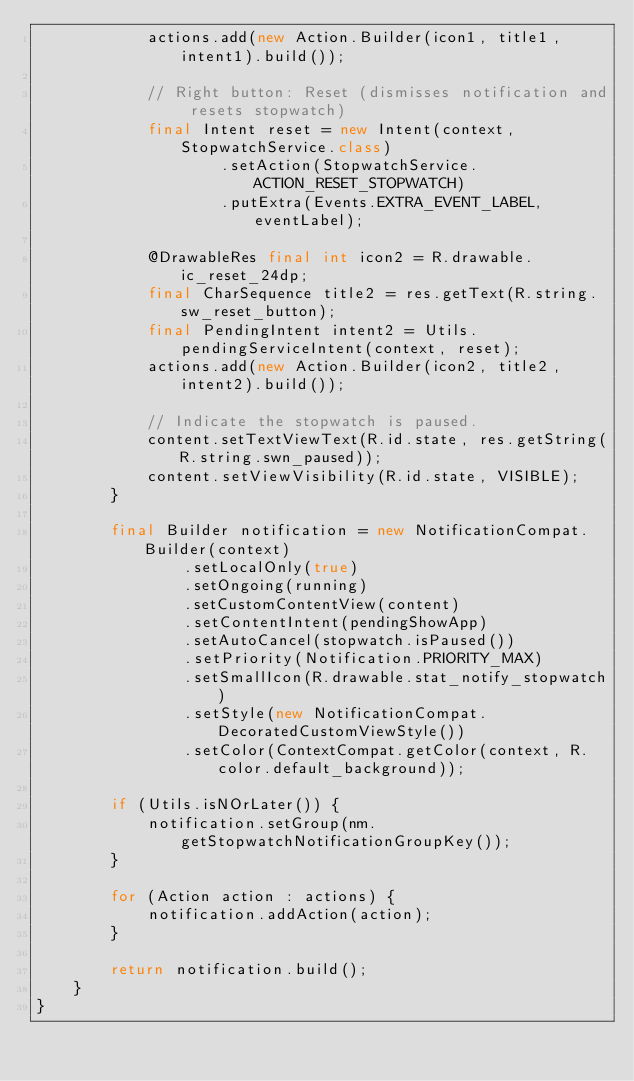Convert code to text. <code><loc_0><loc_0><loc_500><loc_500><_Java_>            actions.add(new Action.Builder(icon1, title1, intent1).build());

            // Right button: Reset (dismisses notification and resets stopwatch)
            final Intent reset = new Intent(context, StopwatchService.class)
                    .setAction(StopwatchService.ACTION_RESET_STOPWATCH)
                    .putExtra(Events.EXTRA_EVENT_LABEL, eventLabel);

            @DrawableRes final int icon2 = R.drawable.ic_reset_24dp;
            final CharSequence title2 = res.getText(R.string.sw_reset_button);
            final PendingIntent intent2 = Utils.pendingServiceIntent(context, reset);
            actions.add(new Action.Builder(icon2, title2, intent2).build());

            // Indicate the stopwatch is paused.
            content.setTextViewText(R.id.state, res.getString(R.string.swn_paused));
            content.setViewVisibility(R.id.state, VISIBLE);
        }

        final Builder notification = new NotificationCompat.Builder(context)
                .setLocalOnly(true)
                .setOngoing(running)
                .setCustomContentView(content)
                .setContentIntent(pendingShowApp)
                .setAutoCancel(stopwatch.isPaused())
                .setPriority(Notification.PRIORITY_MAX)
                .setSmallIcon(R.drawable.stat_notify_stopwatch)
                .setStyle(new NotificationCompat.DecoratedCustomViewStyle())
                .setColor(ContextCompat.getColor(context, R.color.default_background));

        if (Utils.isNOrLater()) {
            notification.setGroup(nm.getStopwatchNotificationGroupKey());
        }

        for (Action action : actions) {
            notification.addAction(action);
        }

        return notification.build();
    }
}
</code> 